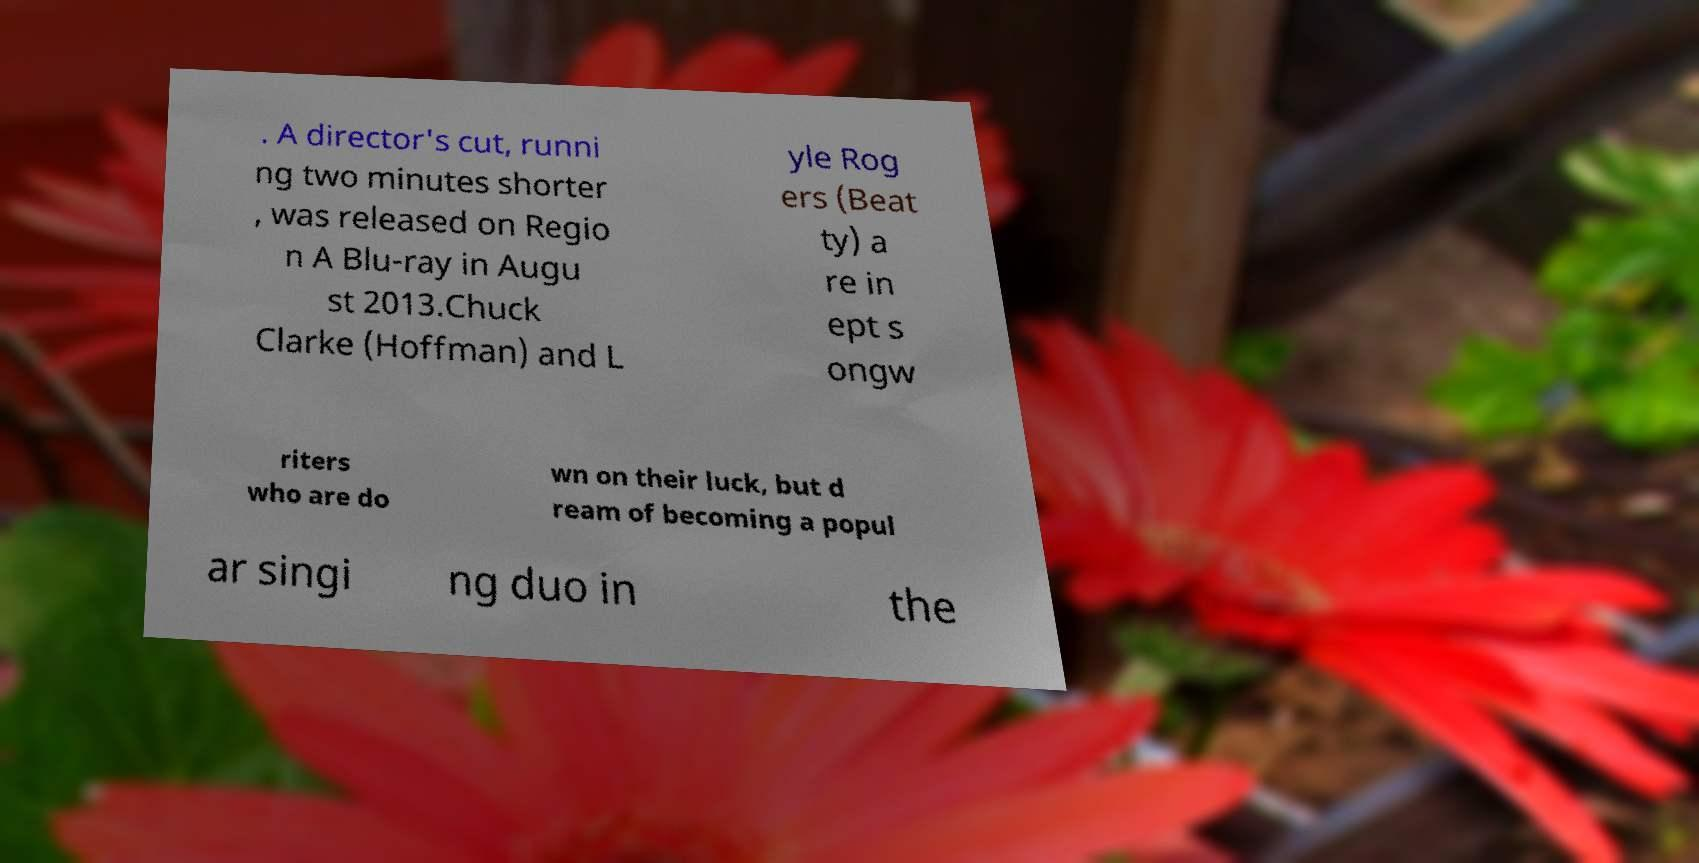What messages or text are displayed in this image? I need them in a readable, typed format. . A director's cut, runni ng two minutes shorter , was released on Regio n A Blu-ray in Augu st 2013.Chuck Clarke (Hoffman) and L yle Rog ers (Beat ty) a re in ept s ongw riters who are do wn on their luck, but d ream of becoming a popul ar singi ng duo in the 